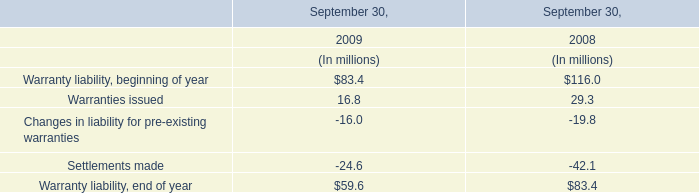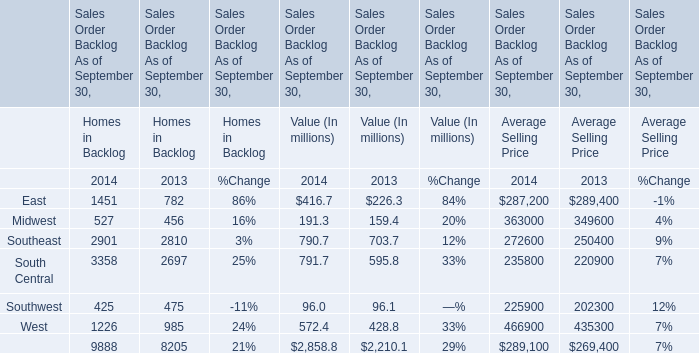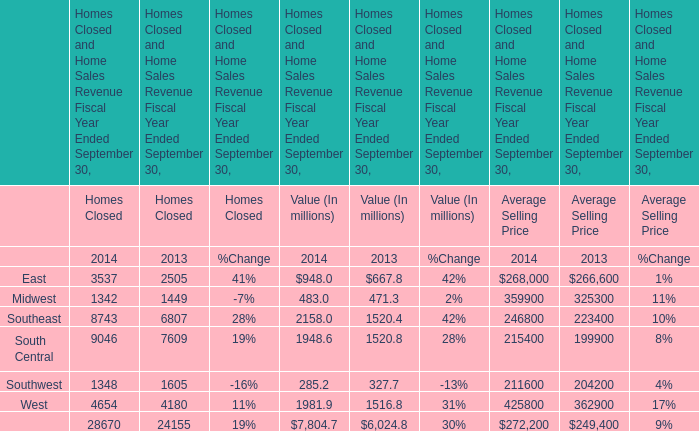Which year is Southwest for Value (In millions) the least? 
Answer: 2014. 